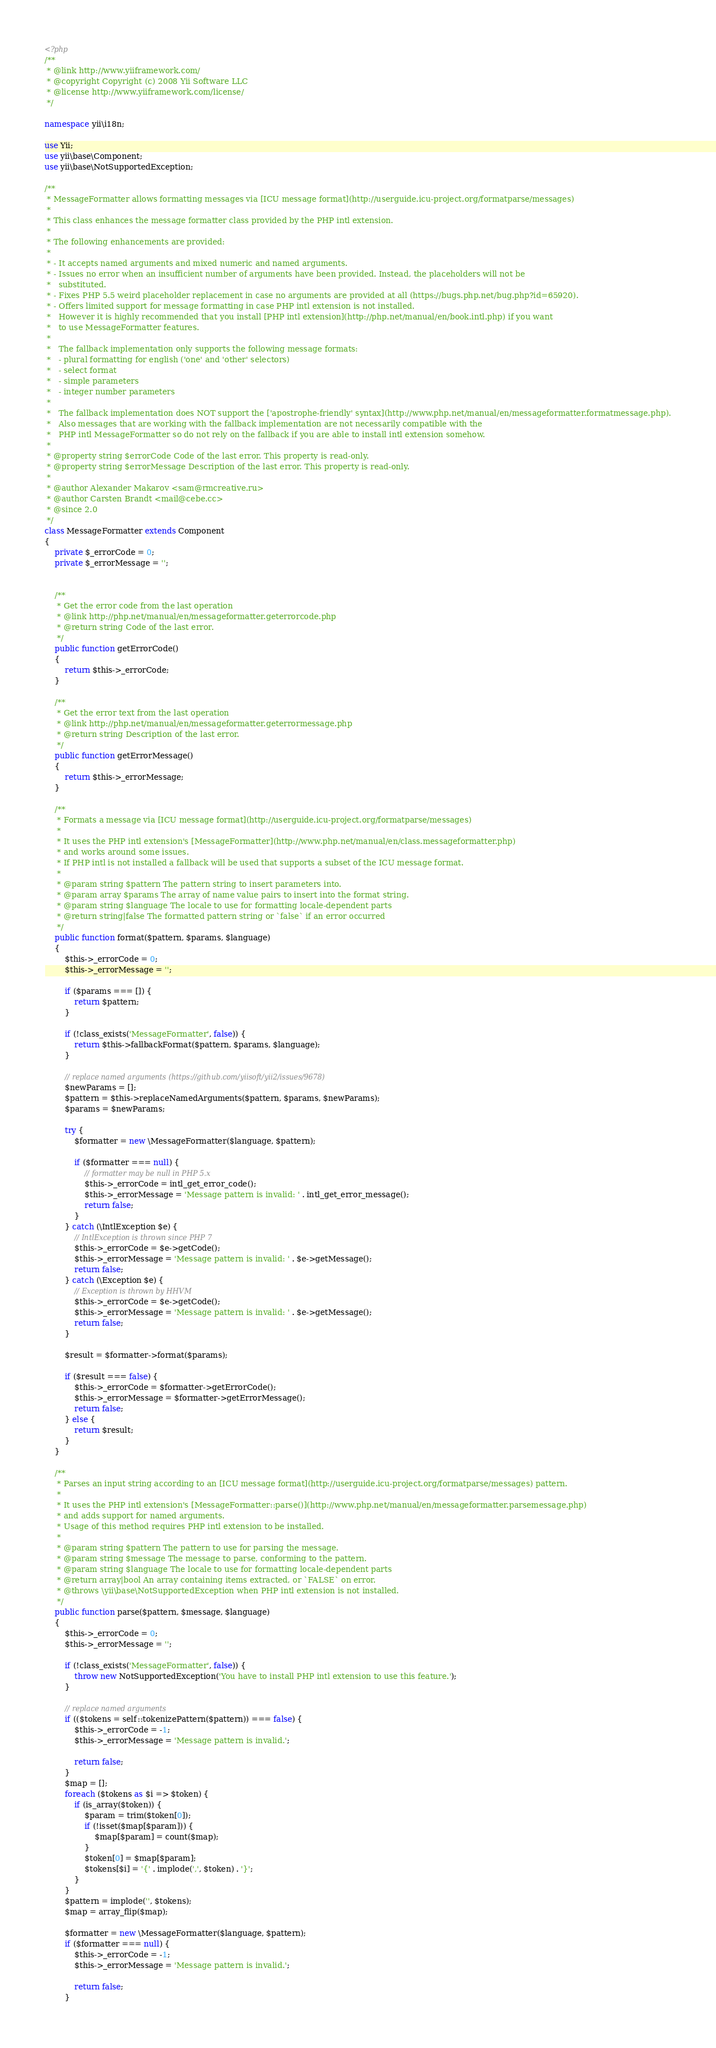Convert code to text. <code><loc_0><loc_0><loc_500><loc_500><_PHP_><?php
/**
 * @link http://www.yiiframework.com/
 * @copyright Copyright (c) 2008 Yii Software LLC
 * @license http://www.yiiframework.com/license/
 */

namespace yii\i18n;

use Yii;
use yii\base\Component;
use yii\base\NotSupportedException;

/**
 * MessageFormatter allows formatting messages via [ICU message format](http://userguide.icu-project.org/formatparse/messages)
 *
 * This class enhances the message formatter class provided by the PHP intl extension.
 *
 * The following enhancements are provided:
 *
 * - It accepts named arguments and mixed numeric and named arguments.
 * - Issues no error when an insufficient number of arguments have been provided. Instead, the placeholders will not be
 *   substituted.
 * - Fixes PHP 5.5 weird placeholder replacement in case no arguments are provided at all (https://bugs.php.net/bug.php?id=65920).
 * - Offers limited support for message formatting in case PHP intl extension is not installed.
 *   However it is highly recommended that you install [PHP intl extension](http://php.net/manual/en/book.intl.php) if you want
 *   to use MessageFormatter features.
 *
 *   The fallback implementation only supports the following message formats:
 *   - plural formatting for english ('one' and 'other' selectors)
 *   - select format
 *   - simple parameters
 *   - integer number parameters
 *
 *   The fallback implementation does NOT support the ['apostrophe-friendly' syntax](http://www.php.net/manual/en/messageformatter.formatmessage.php).
 *   Also messages that are working with the fallback implementation are not necessarily compatible with the
 *   PHP intl MessageFormatter so do not rely on the fallback if you are able to install intl extension somehow.
 *
 * @property string $errorCode Code of the last error. This property is read-only.
 * @property string $errorMessage Description of the last error. This property is read-only.
 *
 * @author Alexander Makarov <sam@rmcreative.ru>
 * @author Carsten Brandt <mail@cebe.cc>
 * @since 2.0
 */
class MessageFormatter extends Component
{
    private $_errorCode = 0;
    private $_errorMessage = '';


    /**
     * Get the error code from the last operation
     * @link http://php.net/manual/en/messageformatter.geterrorcode.php
     * @return string Code of the last error.
     */
    public function getErrorCode()
    {
        return $this->_errorCode;
    }

    /**
     * Get the error text from the last operation
     * @link http://php.net/manual/en/messageformatter.geterrormessage.php
     * @return string Description of the last error.
     */
    public function getErrorMessage()
    {
        return $this->_errorMessage;
    }

    /**
     * Formats a message via [ICU message format](http://userguide.icu-project.org/formatparse/messages)
     *
     * It uses the PHP intl extension's [MessageFormatter](http://www.php.net/manual/en/class.messageformatter.php)
     * and works around some issues.
     * If PHP intl is not installed a fallback will be used that supports a subset of the ICU message format.
     *
     * @param string $pattern The pattern string to insert parameters into.
     * @param array $params The array of name value pairs to insert into the format string.
     * @param string $language The locale to use for formatting locale-dependent parts
     * @return string|false The formatted pattern string or `false` if an error occurred
     */
    public function format($pattern, $params, $language)
    {
        $this->_errorCode = 0;
        $this->_errorMessage = '';

        if ($params === []) {
            return $pattern;
        }

        if (!class_exists('MessageFormatter', false)) {
            return $this->fallbackFormat($pattern, $params, $language);
        }

        // replace named arguments (https://github.com/yiisoft/yii2/issues/9678)
        $newParams = [];
        $pattern = $this->replaceNamedArguments($pattern, $params, $newParams);
        $params = $newParams;

        try {
            $formatter = new \MessageFormatter($language, $pattern);

            if ($formatter === null) {
                // formatter may be null in PHP 5.x
                $this->_errorCode = intl_get_error_code();
                $this->_errorMessage = 'Message pattern is invalid: ' . intl_get_error_message();
                return false;
            }
        } catch (\IntlException $e) {
            // IntlException is thrown since PHP 7
            $this->_errorCode = $e->getCode();
            $this->_errorMessage = 'Message pattern is invalid: ' . $e->getMessage();
            return false;
        } catch (\Exception $e) {
            // Exception is thrown by HHVM
            $this->_errorCode = $e->getCode();
            $this->_errorMessage = 'Message pattern is invalid: ' . $e->getMessage();
            return false;
        }

        $result = $formatter->format($params);

        if ($result === false) {
            $this->_errorCode = $formatter->getErrorCode();
            $this->_errorMessage = $formatter->getErrorMessage();
            return false;
        } else {
            return $result;
        }
    }

    /**
     * Parses an input string according to an [ICU message format](http://userguide.icu-project.org/formatparse/messages) pattern.
     *
     * It uses the PHP intl extension's [MessageFormatter::parse()](http://www.php.net/manual/en/messageformatter.parsemessage.php)
     * and adds support for named arguments.
     * Usage of this method requires PHP intl extension to be installed.
     *
     * @param string $pattern The pattern to use for parsing the message.
     * @param string $message The message to parse, conforming to the pattern.
     * @param string $language The locale to use for formatting locale-dependent parts
     * @return array|bool An array containing items extracted, or `FALSE` on error.
     * @throws \yii\base\NotSupportedException when PHP intl extension is not installed.
     */
    public function parse($pattern, $message, $language)
    {
        $this->_errorCode = 0;
        $this->_errorMessage = '';

        if (!class_exists('MessageFormatter', false)) {
            throw new NotSupportedException('You have to install PHP intl extension to use this feature.');
        }

        // replace named arguments
        if (($tokens = self::tokenizePattern($pattern)) === false) {
            $this->_errorCode = -1;
            $this->_errorMessage = 'Message pattern is invalid.';

            return false;
        }
        $map = [];
        foreach ($tokens as $i => $token) {
            if (is_array($token)) {
                $param = trim($token[0]);
                if (!isset($map[$param])) {
                    $map[$param] = count($map);
                }
                $token[0] = $map[$param];
                $tokens[$i] = '{' . implode(',', $token) . '}';
            }
        }
        $pattern = implode('', $tokens);
        $map = array_flip($map);

        $formatter = new \MessageFormatter($language, $pattern);
        if ($formatter === null) {
            $this->_errorCode = -1;
            $this->_errorMessage = 'Message pattern is invalid.';

            return false;
        }</code> 